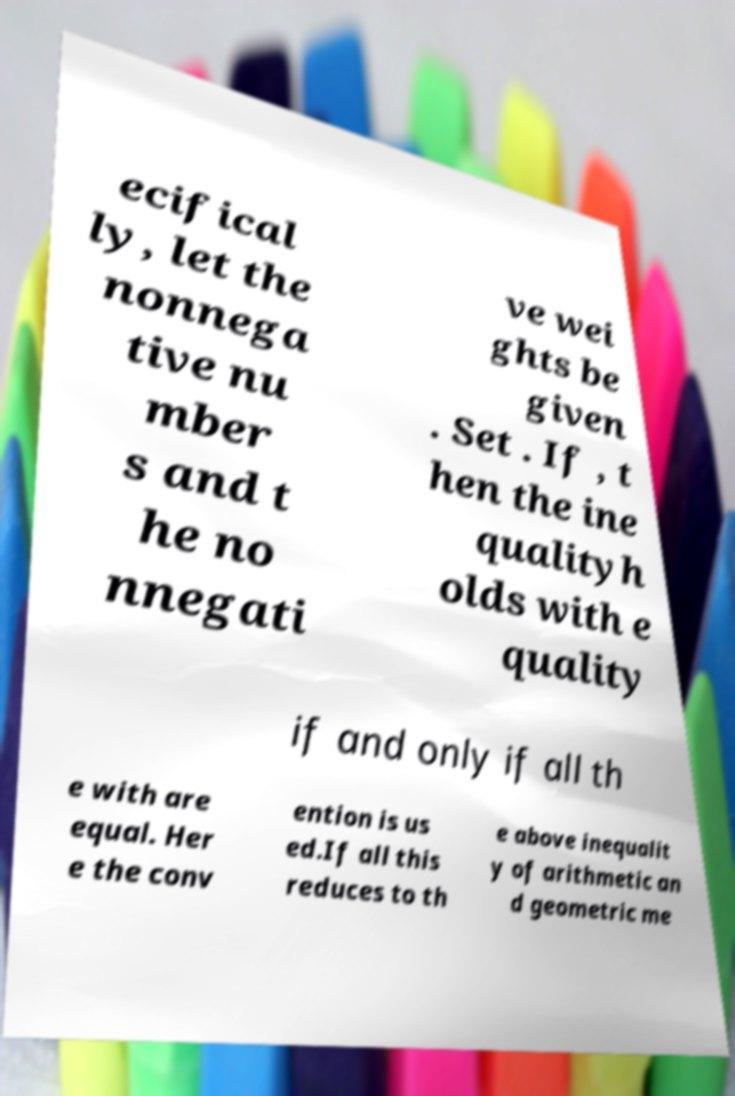Could you extract and type out the text from this image? ecifical ly, let the nonnega tive nu mber s and t he no nnegati ve wei ghts be given . Set . If , t hen the ine qualityh olds with e quality if and only if all th e with are equal. Her e the conv ention is us ed.If all this reduces to th e above inequalit y of arithmetic an d geometric me 